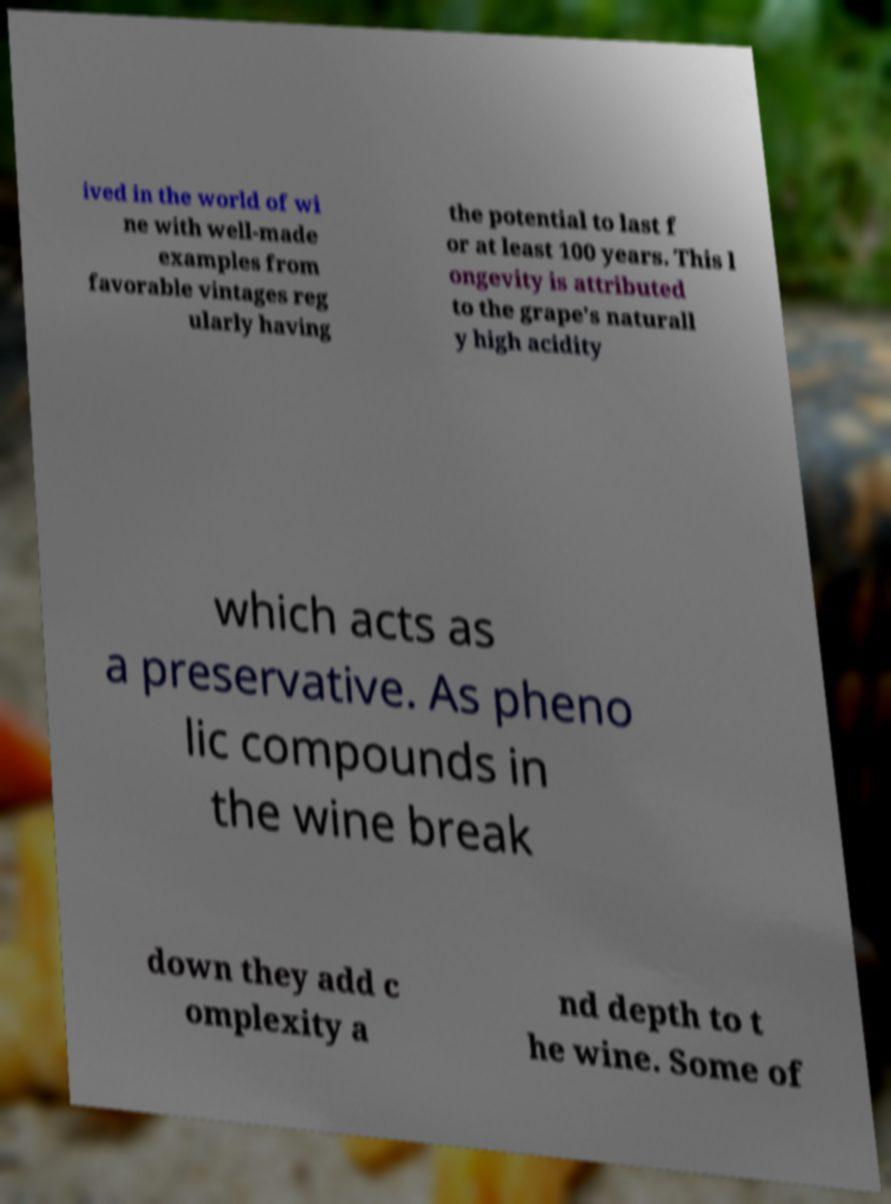There's text embedded in this image that I need extracted. Can you transcribe it verbatim? ived in the world of wi ne with well-made examples from favorable vintages reg ularly having the potential to last f or at least 100 years. This l ongevity is attributed to the grape's naturall y high acidity which acts as a preservative. As pheno lic compounds in the wine break down they add c omplexity a nd depth to t he wine. Some of 